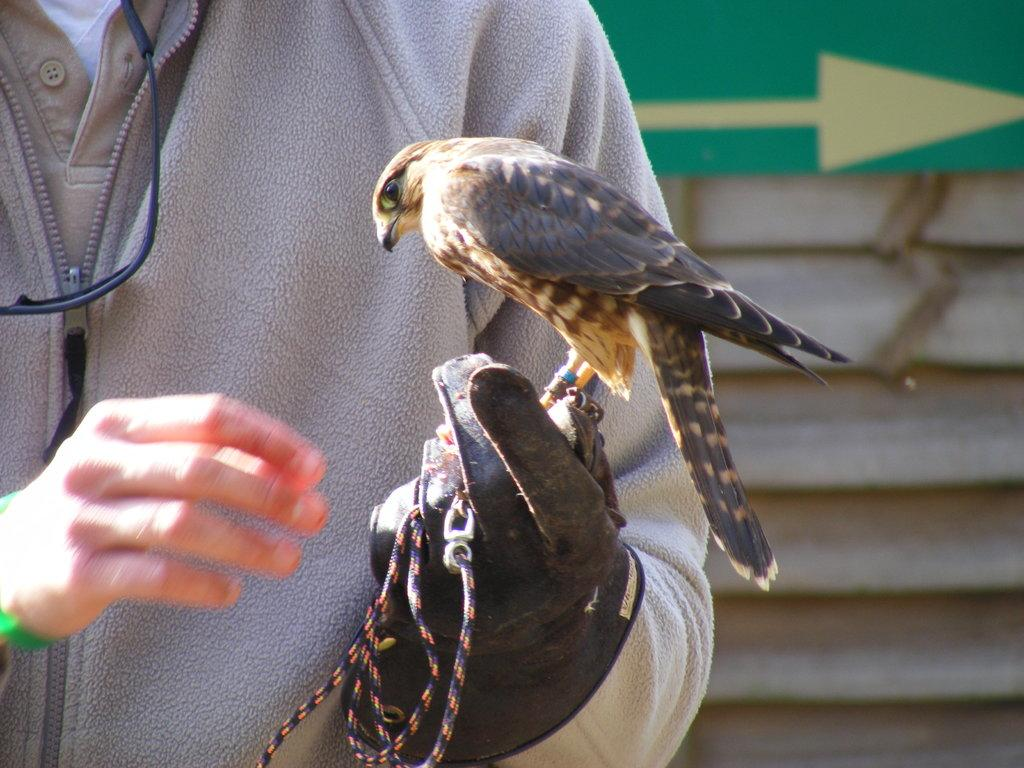What is on the left side of the image? There is a person on the left side of the image. What is the person wearing? The person is wearing a jacket. What is the person holding in their hand? The person is holding a bird in their hand. What else is the person holding? The person is holding a thread. What can be seen in the background of the image? There are stairs and a green color board visible in the background of the image. Can you see any hills or harbors in the image? No, there are no hills or harbors present in the image. 